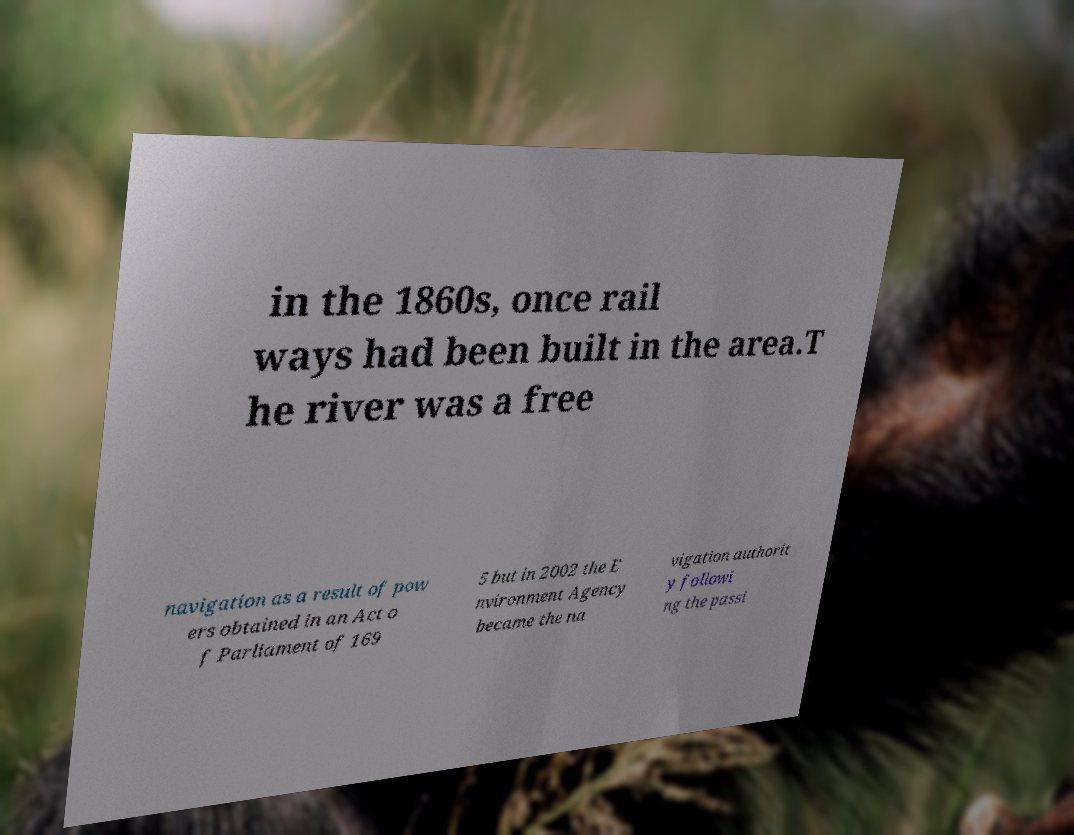I need the written content from this picture converted into text. Can you do that? in the 1860s, once rail ways had been built in the area.T he river was a free navigation as a result of pow ers obtained in an Act o f Parliament of 169 5 but in 2002 the E nvironment Agency became the na vigation authorit y followi ng the passi 